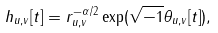Convert formula to latex. <formula><loc_0><loc_0><loc_500><loc_500>h _ { u , v } [ t ] = r _ { u , v } ^ { - \alpha / 2 } \exp ( \sqrt { - 1 } \theta _ { u , v } [ t ] ) ,</formula> 